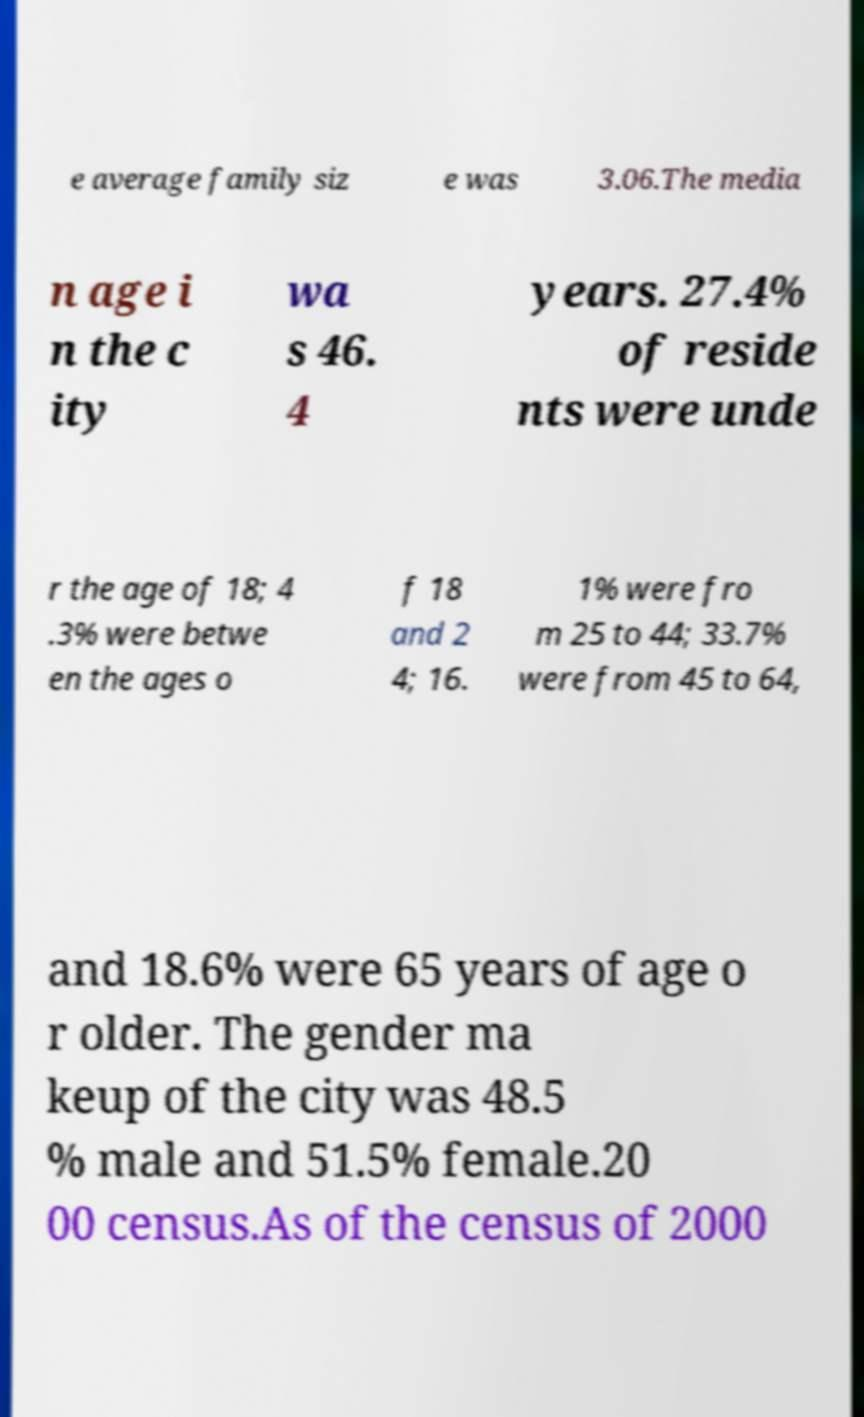Please read and relay the text visible in this image. What does it say? e average family siz e was 3.06.The media n age i n the c ity wa s 46. 4 years. 27.4% of reside nts were unde r the age of 18; 4 .3% were betwe en the ages o f 18 and 2 4; 16. 1% were fro m 25 to 44; 33.7% were from 45 to 64, and 18.6% were 65 years of age o r older. The gender ma keup of the city was 48.5 % male and 51.5% female.20 00 census.As of the census of 2000 